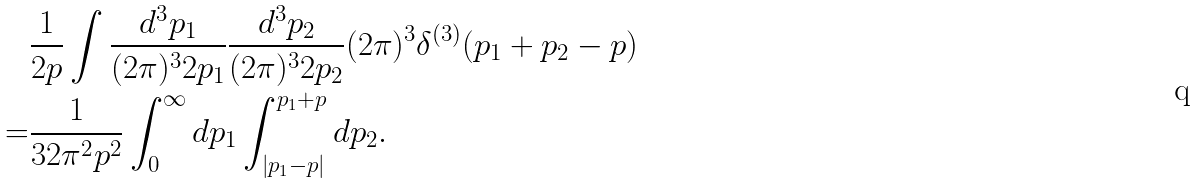<formula> <loc_0><loc_0><loc_500><loc_500>& \frac { 1 } { 2 p } \int \frac { d ^ { 3 } p _ { 1 } } { ( 2 \pi ) ^ { 3 } 2 p _ { 1 } } \frac { d ^ { 3 } p _ { 2 } } { ( 2 \pi ) ^ { 3 } 2 p _ { 2 } } ( 2 \pi ) ^ { 3 } \delta ^ { ( 3 ) } ( { p } _ { 1 } + { p } _ { 2 } - { p } ) \\ = & \frac { 1 } { 3 2 \pi ^ { 2 } p ^ { 2 } } \int ^ { \infty } _ { 0 } d p _ { 1 } \int ^ { p _ { 1 } + p } _ { | p _ { 1 } - p | } d p _ { 2 } .</formula> 